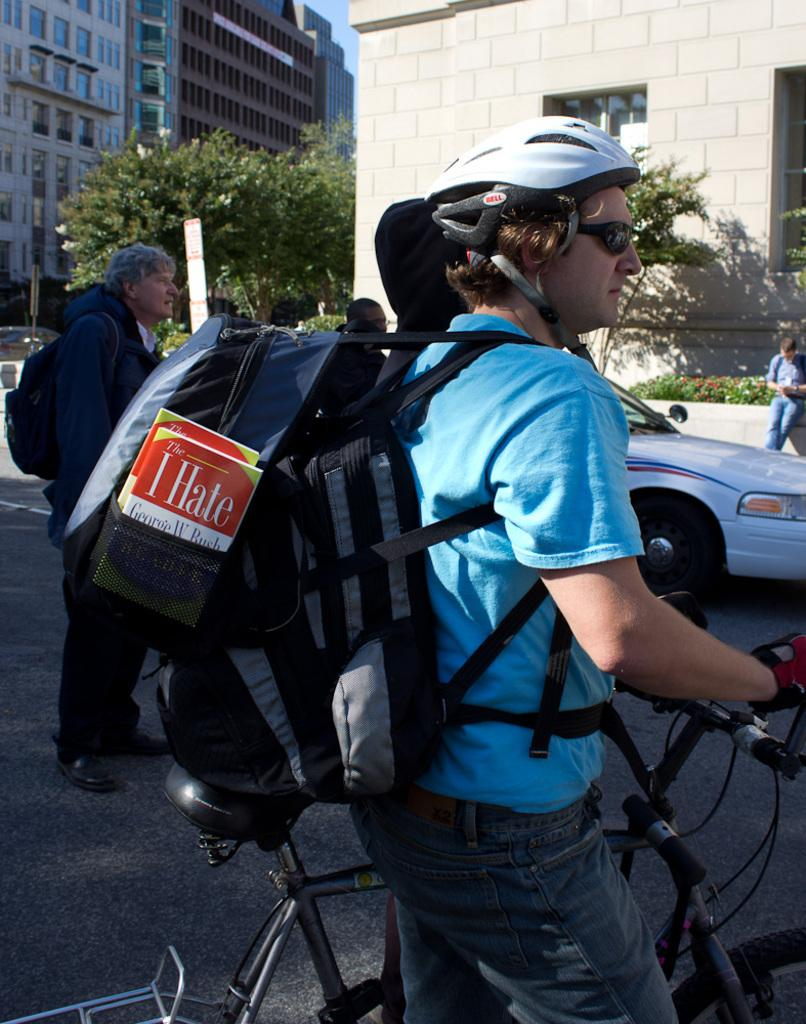<image>
Summarize the visual content of the image. A man riding a bicycle with a book titled "I Hate Geroge W. Bush." in his bag. 